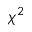Convert formula to latex. <formula><loc_0><loc_0><loc_500><loc_500>\chi ^ { 2 }</formula> 